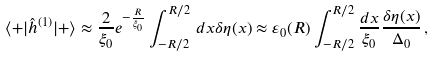Convert formula to latex. <formula><loc_0><loc_0><loc_500><loc_500>\langle + | { \hat { h } } ^ { ( 1 ) } | + \rangle \approx \frac { 2 } { \xi _ { 0 } } e ^ { - \frac { R } { \xi _ { 0 } } } \int _ { - R / 2 } ^ { R / 2 } \, d x \delta \eta ( x ) \approx \varepsilon _ { 0 } ( R ) \int _ { - R / 2 } ^ { R / 2 } \frac { d x } { \xi _ { 0 } } \frac { \delta \eta ( x ) } { \Delta _ { 0 } } \, ,</formula> 